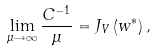<formula> <loc_0><loc_0><loc_500><loc_500>\lim _ { \mu \rightarrow \infty } \frac { C ^ { - 1 } } \mu = J _ { V } \left ( { w } ^ { * } \right ) ,</formula> 